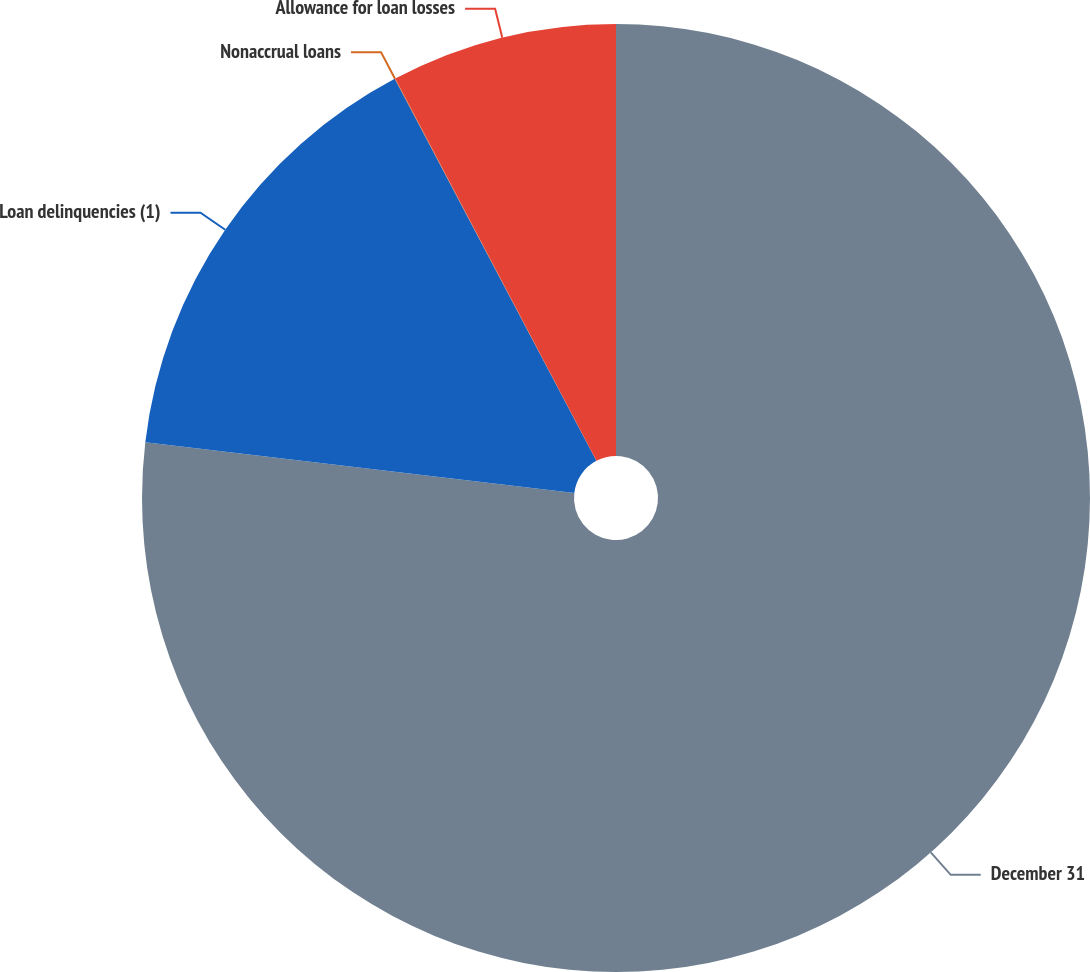Convert chart to OTSL. <chart><loc_0><loc_0><loc_500><loc_500><pie_chart><fcel>December 31<fcel>Loan delinquencies (1)<fcel>Nonaccrual loans<fcel>Allowance for loan losses<nl><fcel>76.88%<fcel>15.39%<fcel>0.02%<fcel>7.71%<nl></chart> 